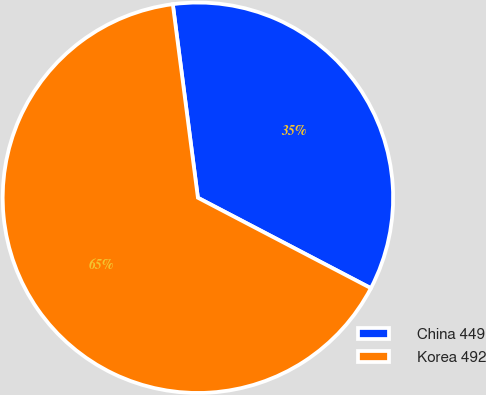<chart> <loc_0><loc_0><loc_500><loc_500><pie_chart><fcel>China 449<fcel>Korea 492<nl><fcel>34.72%<fcel>65.28%<nl></chart> 